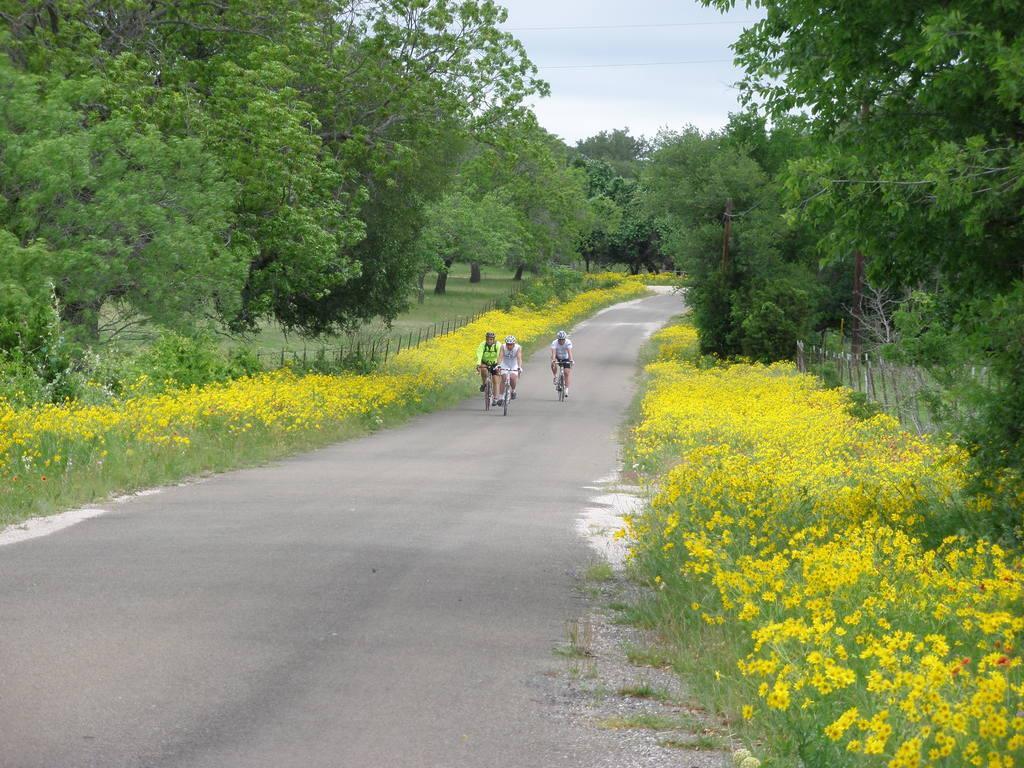Could you give a brief overview of what you see in this image? In the picture we can see a road with three people are riding bicycles, and on the both the sides of the road we can see grass plants with yellow colored flowers and trees and in the background also we can see many trees and top of it we can see the sky. 